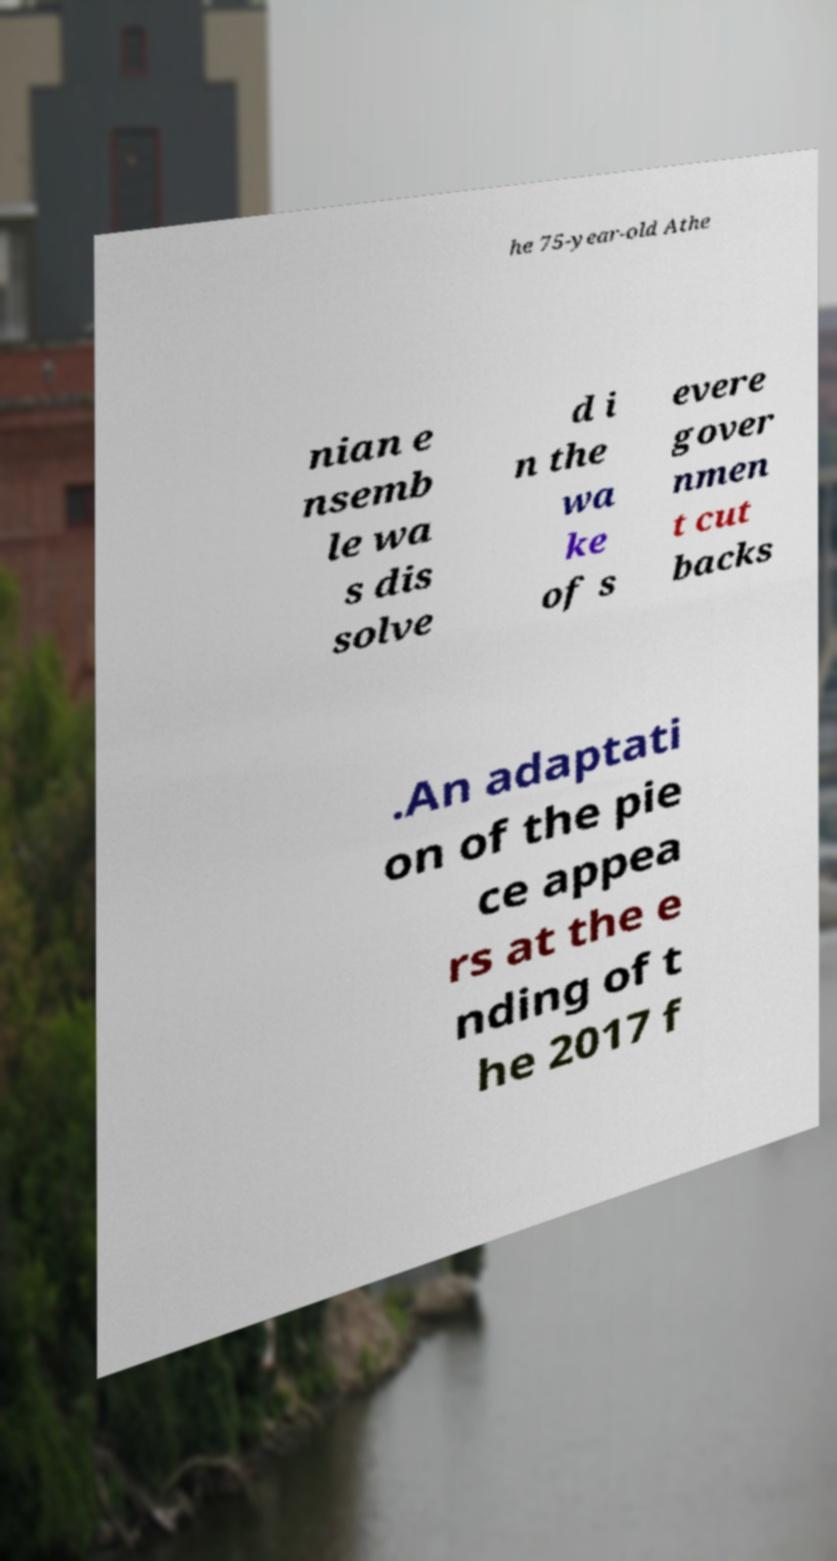Please identify and transcribe the text found in this image. he 75-year-old Athe nian e nsemb le wa s dis solve d i n the wa ke of s evere gover nmen t cut backs .An adaptati on of the pie ce appea rs at the e nding of t he 2017 f 